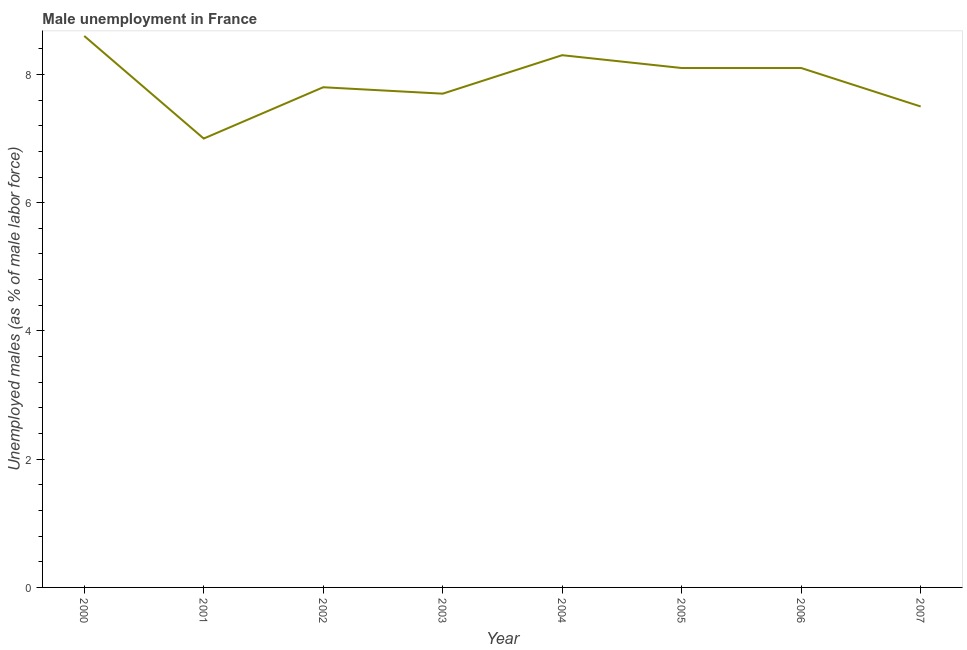Across all years, what is the maximum unemployed males population?
Provide a succinct answer. 8.6. In which year was the unemployed males population minimum?
Offer a very short reply. 2001. What is the sum of the unemployed males population?
Keep it short and to the point. 63.1. What is the difference between the unemployed males population in 2004 and 2005?
Keep it short and to the point. 0.2. What is the average unemployed males population per year?
Offer a very short reply. 7.89. What is the median unemployed males population?
Give a very brief answer. 7.95. In how many years, is the unemployed males population greater than 6 %?
Provide a succinct answer. 8. Do a majority of the years between 2006 and 2000 (inclusive) have unemployed males population greater than 2 %?
Make the answer very short. Yes. What is the ratio of the unemployed males population in 2001 to that in 2002?
Provide a short and direct response. 0.9. Is the difference between the unemployed males population in 2001 and 2005 greater than the difference between any two years?
Provide a succinct answer. No. What is the difference between the highest and the second highest unemployed males population?
Your answer should be very brief. 0.3. Is the sum of the unemployed males population in 2002 and 2006 greater than the maximum unemployed males population across all years?
Offer a very short reply. Yes. What is the difference between the highest and the lowest unemployed males population?
Your answer should be compact. 1.6. Does the unemployed males population monotonically increase over the years?
Give a very brief answer. No. How many lines are there?
Give a very brief answer. 1. How many years are there in the graph?
Provide a short and direct response. 8. Does the graph contain any zero values?
Ensure brevity in your answer.  No. What is the title of the graph?
Your answer should be very brief. Male unemployment in France. What is the label or title of the Y-axis?
Make the answer very short. Unemployed males (as % of male labor force). What is the Unemployed males (as % of male labor force) of 2000?
Your response must be concise. 8.6. What is the Unemployed males (as % of male labor force) of 2001?
Your answer should be very brief. 7. What is the Unemployed males (as % of male labor force) of 2002?
Offer a very short reply. 7.8. What is the Unemployed males (as % of male labor force) in 2003?
Offer a terse response. 7.7. What is the Unemployed males (as % of male labor force) in 2004?
Offer a very short reply. 8.3. What is the Unemployed males (as % of male labor force) of 2005?
Your response must be concise. 8.1. What is the Unemployed males (as % of male labor force) of 2006?
Your answer should be very brief. 8.1. What is the difference between the Unemployed males (as % of male labor force) in 2000 and 2003?
Offer a terse response. 0.9. What is the difference between the Unemployed males (as % of male labor force) in 2000 and 2004?
Offer a very short reply. 0.3. What is the difference between the Unemployed males (as % of male labor force) in 2000 and 2005?
Offer a very short reply. 0.5. What is the difference between the Unemployed males (as % of male labor force) in 2001 and 2002?
Offer a terse response. -0.8. What is the difference between the Unemployed males (as % of male labor force) in 2001 and 2003?
Make the answer very short. -0.7. What is the difference between the Unemployed males (as % of male labor force) in 2001 and 2005?
Provide a succinct answer. -1.1. What is the difference between the Unemployed males (as % of male labor force) in 2001 and 2007?
Your answer should be compact. -0.5. What is the difference between the Unemployed males (as % of male labor force) in 2003 and 2004?
Make the answer very short. -0.6. What is the difference between the Unemployed males (as % of male labor force) in 2003 and 2005?
Offer a terse response. -0.4. What is the difference between the Unemployed males (as % of male labor force) in 2003 and 2007?
Make the answer very short. 0.2. What is the difference between the Unemployed males (as % of male labor force) in 2004 and 2007?
Provide a succinct answer. 0.8. What is the difference between the Unemployed males (as % of male labor force) in 2005 and 2006?
Your response must be concise. 0. What is the difference between the Unemployed males (as % of male labor force) in 2006 and 2007?
Keep it short and to the point. 0.6. What is the ratio of the Unemployed males (as % of male labor force) in 2000 to that in 2001?
Offer a very short reply. 1.23. What is the ratio of the Unemployed males (as % of male labor force) in 2000 to that in 2002?
Keep it short and to the point. 1.1. What is the ratio of the Unemployed males (as % of male labor force) in 2000 to that in 2003?
Your answer should be compact. 1.12. What is the ratio of the Unemployed males (as % of male labor force) in 2000 to that in 2004?
Offer a very short reply. 1.04. What is the ratio of the Unemployed males (as % of male labor force) in 2000 to that in 2005?
Your answer should be compact. 1.06. What is the ratio of the Unemployed males (as % of male labor force) in 2000 to that in 2006?
Offer a very short reply. 1.06. What is the ratio of the Unemployed males (as % of male labor force) in 2000 to that in 2007?
Keep it short and to the point. 1.15. What is the ratio of the Unemployed males (as % of male labor force) in 2001 to that in 2002?
Your answer should be very brief. 0.9. What is the ratio of the Unemployed males (as % of male labor force) in 2001 to that in 2003?
Offer a terse response. 0.91. What is the ratio of the Unemployed males (as % of male labor force) in 2001 to that in 2004?
Your answer should be compact. 0.84. What is the ratio of the Unemployed males (as % of male labor force) in 2001 to that in 2005?
Your answer should be very brief. 0.86. What is the ratio of the Unemployed males (as % of male labor force) in 2001 to that in 2006?
Keep it short and to the point. 0.86. What is the ratio of the Unemployed males (as % of male labor force) in 2001 to that in 2007?
Give a very brief answer. 0.93. What is the ratio of the Unemployed males (as % of male labor force) in 2002 to that in 2004?
Make the answer very short. 0.94. What is the ratio of the Unemployed males (as % of male labor force) in 2002 to that in 2005?
Ensure brevity in your answer.  0.96. What is the ratio of the Unemployed males (as % of male labor force) in 2002 to that in 2006?
Provide a succinct answer. 0.96. What is the ratio of the Unemployed males (as % of male labor force) in 2002 to that in 2007?
Give a very brief answer. 1.04. What is the ratio of the Unemployed males (as % of male labor force) in 2003 to that in 2004?
Keep it short and to the point. 0.93. What is the ratio of the Unemployed males (as % of male labor force) in 2003 to that in 2005?
Provide a short and direct response. 0.95. What is the ratio of the Unemployed males (as % of male labor force) in 2003 to that in 2006?
Keep it short and to the point. 0.95. What is the ratio of the Unemployed males (as % of male labor force) in 2003 to that in 2007?
Provide a succinct answer. 1.03. What is the ratio of the Unemployed males (as % of male labor force) in 2004 to that in 2007?
Offer a terse response. 1.11. What is the ratio of the Unemployed males (as % of male labor force) in 2005 to that in 2006?
Offer a very short reply. 1. 